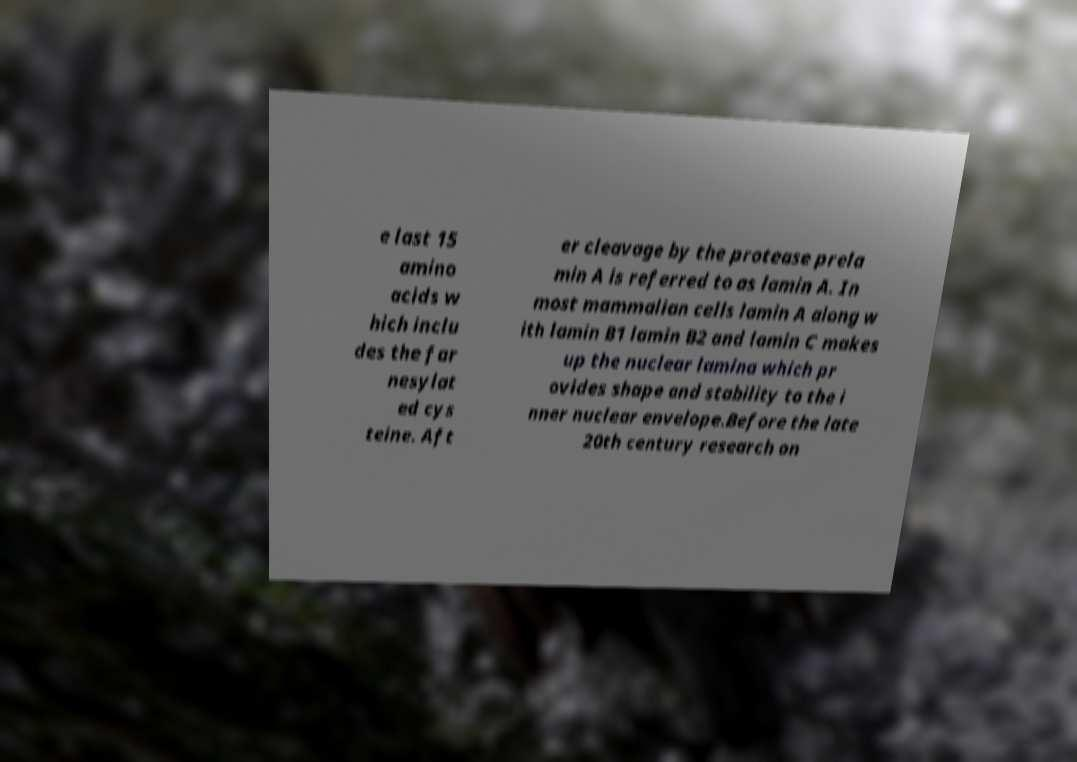Please read and relay the text visible in this image. What does it say? e last 15 amino acids w hich inclu des the far nesylat ed cys teine. Aft er cleavage by the protease prela min A is referred to as lamin A. In most mammalian cells lamin A along w ith lamin B1 lamin B2 and lamin C makes up the nuclear lamina which pr ovides shape and stability to the i nner nuclear envelope.Before the late 20th century research on 